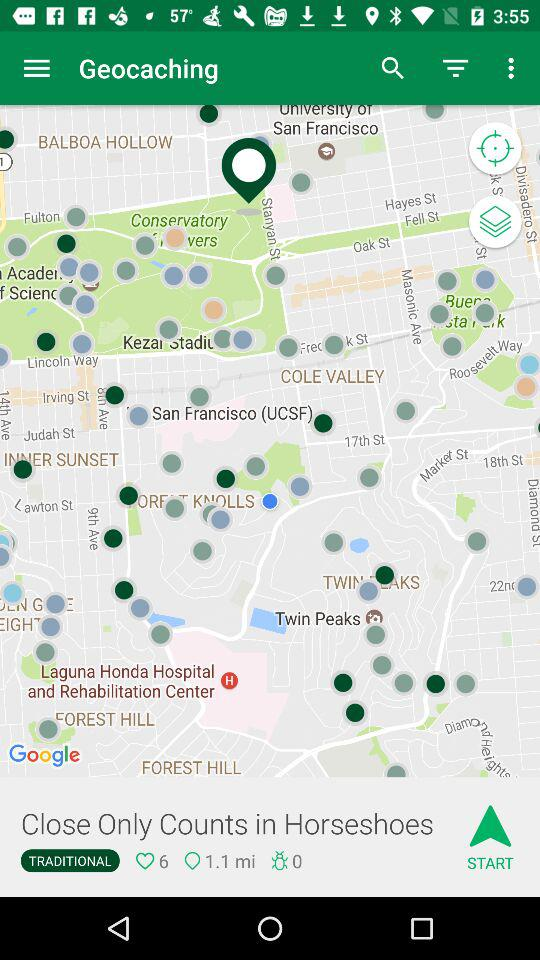What is the distance? The distance is 1.1 miles. 